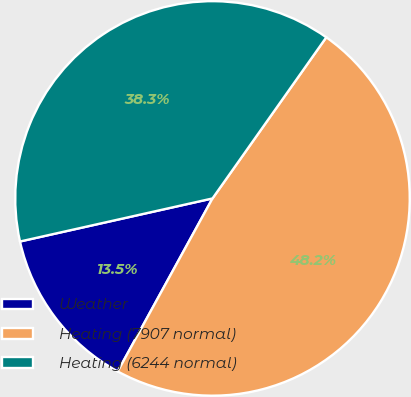<chart> <loc_0><loc_0><loc_500><loc_500><pie_chart><fcel>Weather<fcel>Heating (7907 normal)<fcel>Heating (6244 normal)<nl><fcel>13.52%<fcel>48.19%<fcel>38.29%<nl></chart> 